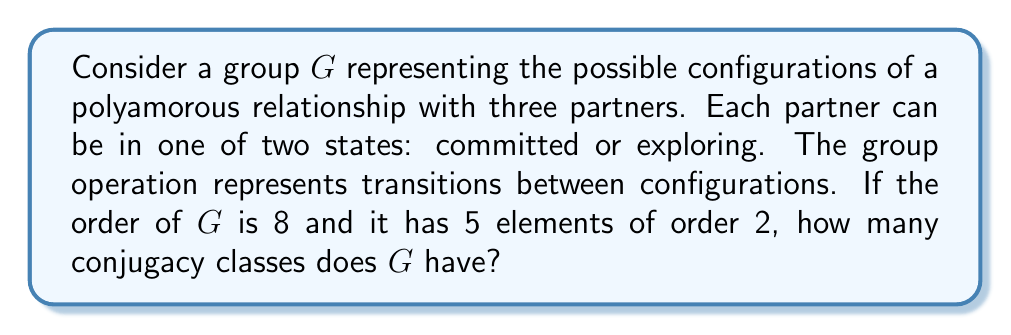Solve this math problem. Let's approach this step-by-step:

1) First, we need to identify the group. Given that $|G| = 8$ and it has 5 elements of order 2, this group must be the dihedral group $D_4$.

2) In $D_4$, we have:
   - 1 identity element (order 1)
   - 5 elements of order 2
   - 2 elements of order 4

3) To find the number of conjugacy classes, we can use the class equation:

   $|G| = |Z(G)| + \sum_{[g] \neq \{e\}} |[g]|$

   where $Z(G)$ is the center of $G$ and $[g]$ represents a non-trivial conjugacy class.

4) In $D_4$:
   - The center $Z(D_4)$ contains only the identity element.
   - The 2 elements of order 4 form a single conjugacy class of size 2.
   - The 5 elements of order 2 are split into two conjugacy classes: one of size 2 and one of size 3.

5) Therefore, the class equation for $D_4$ is:

   $8 = 1 + 2 + 2 + 3$

6) Counting the terms on the right side of the equation gives us the number of conjugacy classes.
Answer: The group $G$ (which is $D_4$) has 4 conjugacy classes. 